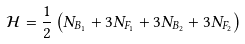<formula> <loc_0><loc_0><loc_500><loc_500>\mathcal { H } = \frac { 1 } { 2 } \left ( N _ { B _ { 1 } } + 3 N _ { F _ { 1 } } + 3 N _ { B _ { 2 } } + 3 N _ { F _ { 2 } } \right )</formula> 